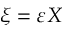<formula> <loc_0><loc_0><loc_500><loc_500>\xi = \varepsilon X</formula> 